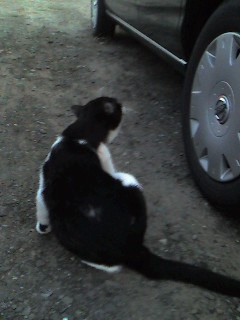Describe the objects in this image and their specific colors. I can see car in darkgray, black, gray, and purple tones and cat in darkgray, black, and gray tones in this image. 